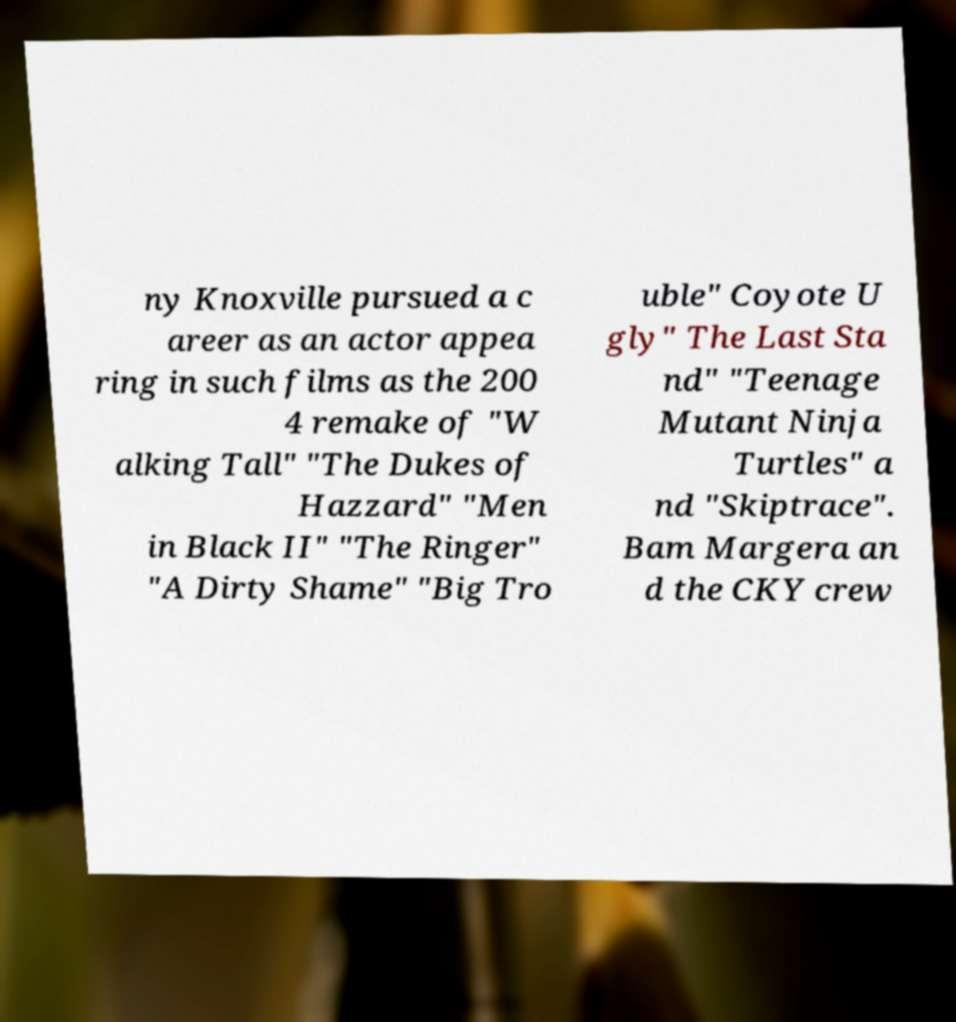Could you extract and type out the text from this image? ny Knoxville pursued a c areer as an actor appea ring in such films as the 200 4 remake of "W alking Tall" "The Dukes of Hazzard" "Men in Black II" "The Ringer" "A Dirty Shame" "Big Tro uble" Coyote U gly" The Last Sta nd" "Teenage Mutant Ninja Turtles" a nd "Skiptrace". Bam Margera an d the CKY crew 